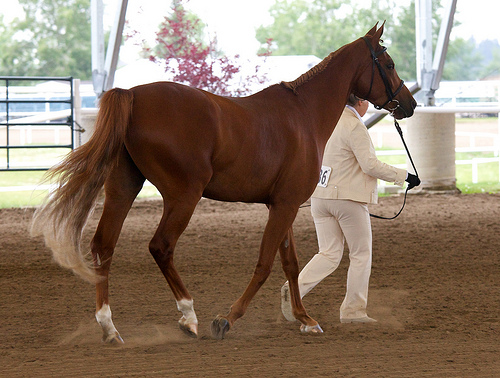<image>
Is the tail behind the person? Yes. From this viewpoint, the tail is positioned behind the person, with the person partially or fully occluding the tail. 